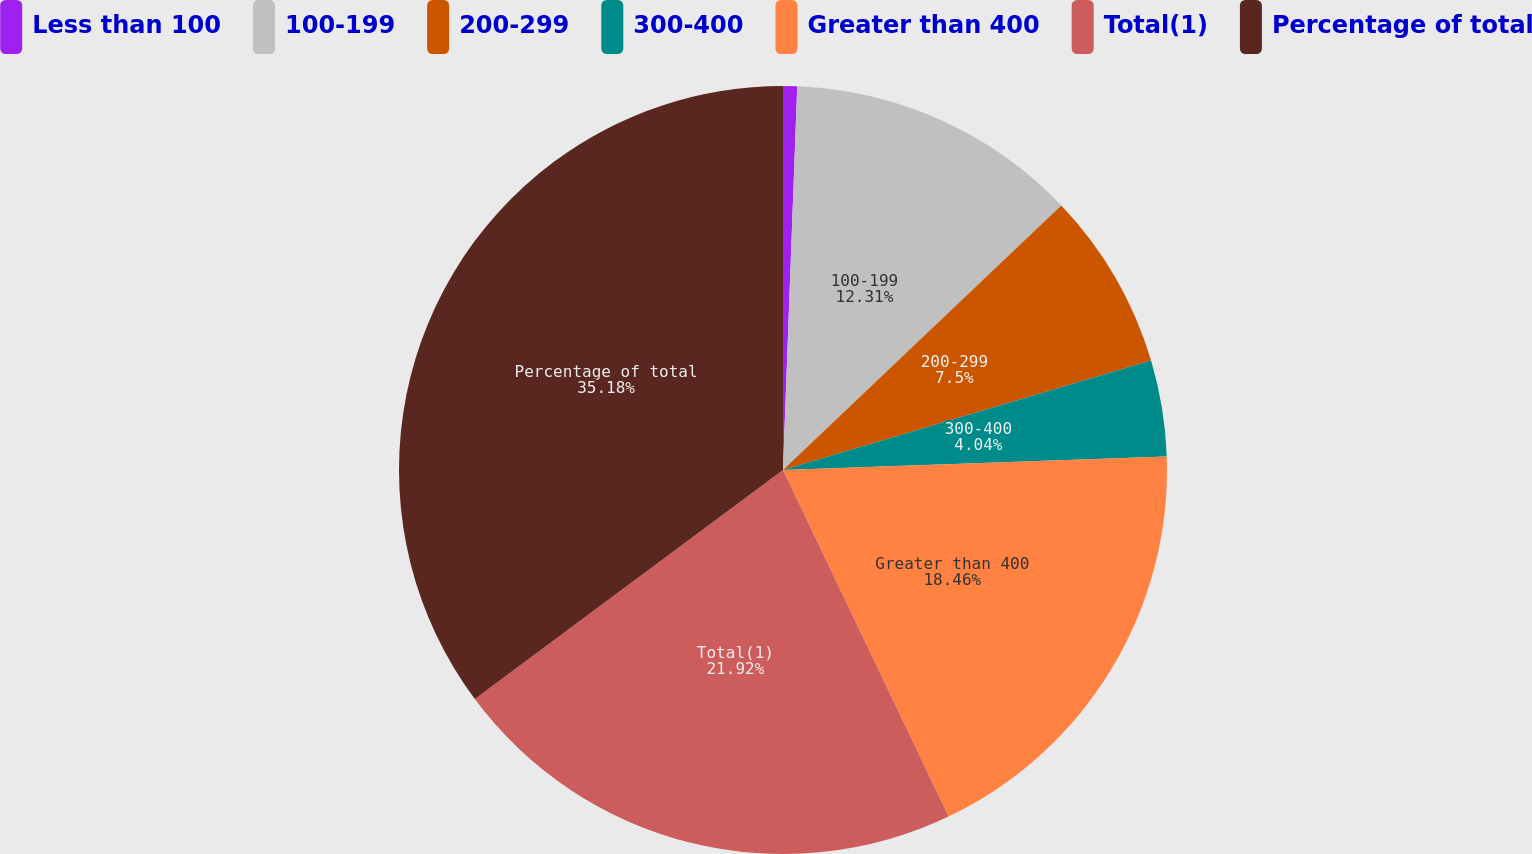<chart> <loc_0><loc_0><loc_500><loc_500><pie_chart><fcel>Less than 100<fcel>100-199<fcel>200-299<fcel>300-400<fcel>Greater than 400<fcel>Total(1)<fcel>Percentage of total<nl><fcel>0.59%<fcel>12.31%<fcel>7.5%<fcel>4.04%<fcel>18.46%<fcel>21.92%<fcel>35.17%<nl></chart> 